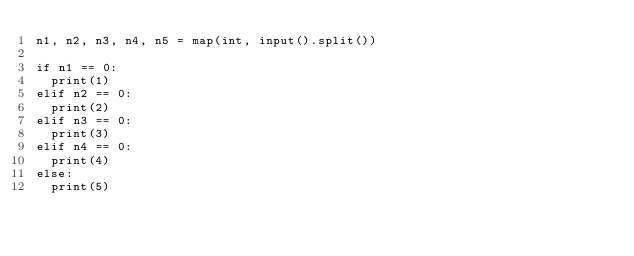<code> <loc_0><loc_0><loc_500><loc_500><_Python_>n1, n2, n3, n4, n5 = map(int, input().split())

if n1 == 0:
  print(1)
elif n2 == 0:
  print(2)
elif n3 == 0:
  print(3)
elif n4 == 0:
  print(4)
else:
  print(5)</code> 